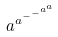<formula> <loc_0><loc_0><loc_500><loc_500>a ^ { a ^ { - ^ { - ^ { a ^ { a } } } } }</formula> 